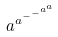<formula> <loc_0><loc_0><loc_500><loc_500>a ^ { a ^ { - ^ { - ^ { a ^ { a } } } } }</formula> 